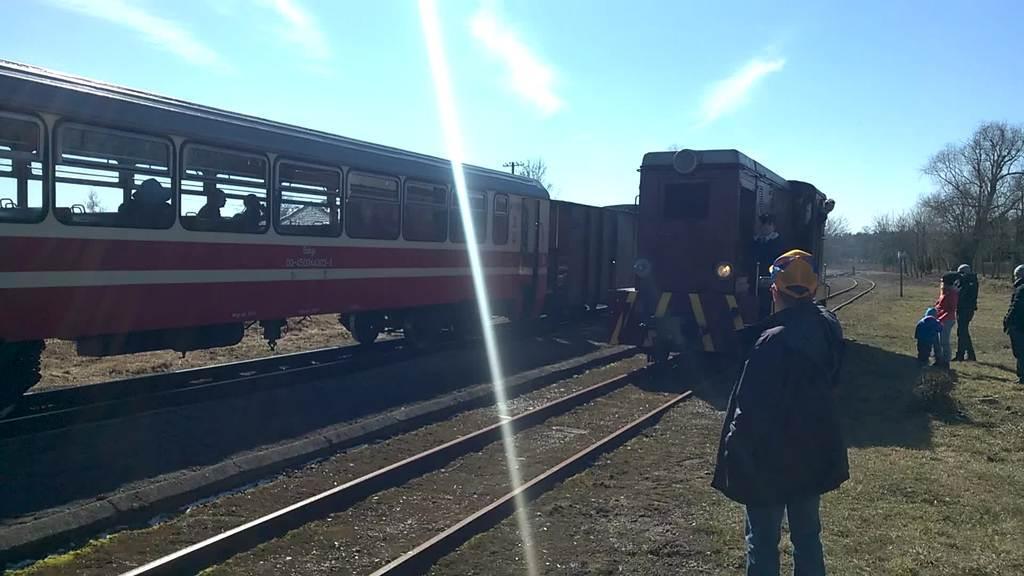Could you give a brief overview of what you see in this image? In this image in the center is one train, in the train there are some people who are sitting. At the bottom there is a railway track and on the right side there are some persons who are standing and in the background there are some trees. On the top of the image there is sky. 